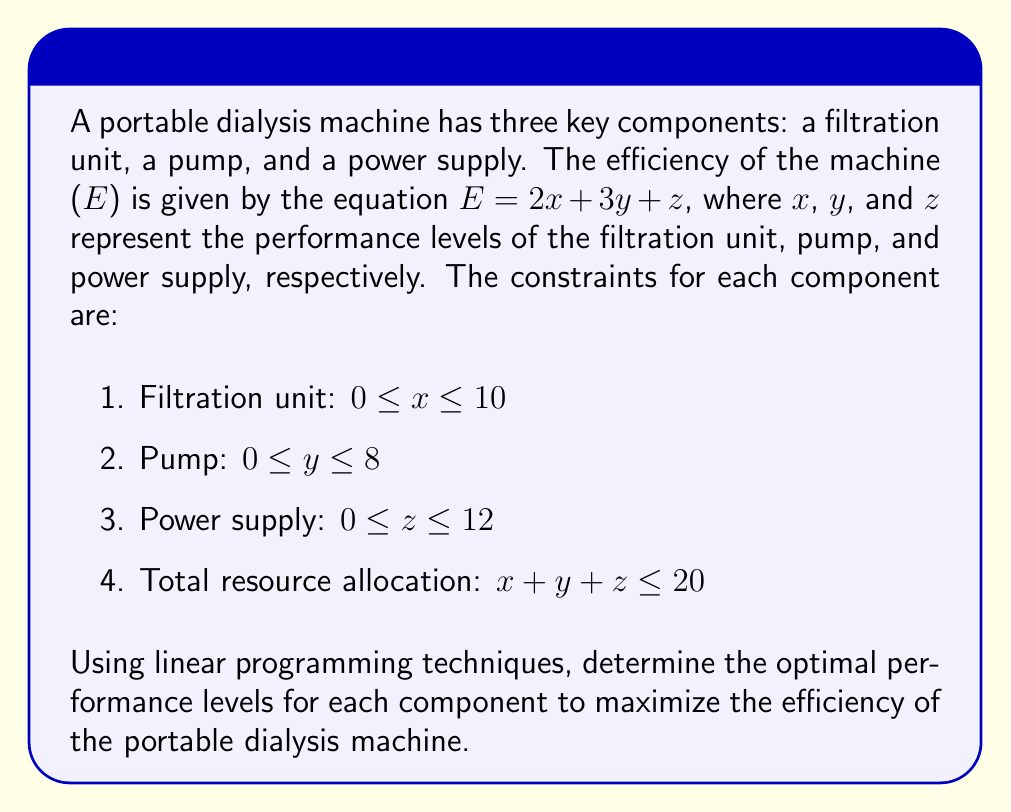Can you answer this question? To solve this linear programming problem, we'll use the simplex method:

1. Define the objective function:
   Maximize $E = 2x + 3y + z$

2. List the constraints:
   $x \leq 10$
   $y \leq 8$
   $z \leq 12$
   $x + y + z \leq 20$
   $x, y, z \geq 0$

3. Convert inequalities to equations by introducing slack variables:
   $x + s_1 = 10$
   $y + s_2 = 8$
   $z + s_3 = 12$
   $x + y + z + s_4 = 20$

4. Set up the initial simplex tableau:

   $$\begin{array}{c|cccc|cccc|c}
   & x & y & z & s_4 & s_1 & s_2 & s_3 & RHS \\
   \hline
   s_1 & 1 & 0 & 0 & 0 & 1 & 0 & 0 & 10 \\
   s_2 & 0 & 1 & 0 & 0 & 0 & 1 & 0 & 8 \\
   s_3 & 0 & 0 & 1 & 0 & 0 & 0 & 1 & 12 \\
   s_4 & 1 & 1 & 1 & 1 & 0 & 0 & 0 & 20 \\
   \hline
   z & -2 & -3 & -1 & 0 & 0 & 0 & 0 & 0
   \end{array}$$

5. Identify the pivot column (most negative in z-row): y (-3)

6. Calculate the ratios and identify the pivot row:
   $10/0 = \infty$
   $8/1 = 8$ (minimum)
   $12/0 = \infty$
   $20/1 = 20$

   Pivot row: s_2 row

7. Perform row operations to get the new tableau:

   $$\begin{array}{c|cccc|cccc|c}
   & x & y & z & s_4 & s_1 & s_2 & s_3 & RHS \\
   \hline
   s_1 & 1 & 0 & 0 & 0 & 1 & 0 & 0 & 10 \\
   y & 0 & 1 & 0 & 0 & 0 & 1 & 0 & 8 \\
   s_3 & 0 & 0 & 1 & 0 & 0 & 0 & 1 & 12 \\
   s_4 & 1 & 0 & 1 & 1 & 0 & -1 & 0 & 12 \\
   \hline
   z & -2 & 0 & -1 & 0 & 0 & 3 & 0 & 24
   \end{array}$$

8. Repeat steps 5-7 until no negative values remain in the z-row:

   Final tableau:

   $$\begin{array}{c|cccc|cccc|c}
   & x & y & z & s_4 & s_1 & s_2 & s_3 & RHS \\
   \hline
   x & 1 & 0 & 0 & 0 & 1 & 0 & 0 & 10 \\
   y & 0 & 1 & 0 & 0 & 0 & 1 & 0 & 8 \\
   z & 0 & 0 & 1 & 0 & 0 & 0 & 1 & 2 \\
   s_4 & 0 & 0 & 0 & 1 & -1 & -1 & -1 & 0 \\
   \hline
   z & 0 & 0 & 0 & 0 & 2 & 3 & 1 & 48
   \end{array}$$

9. Read the optimal solution from the final tableau:
   $x = 10$ (filtration unit)
   $y = 8$ (pump)
   $z = 2$ (power supply)
   Maximum efficiency: $E = 48$
Answer: $x = 10$, $y = 8$, $z = 2$; Maximum efficiency: 48 